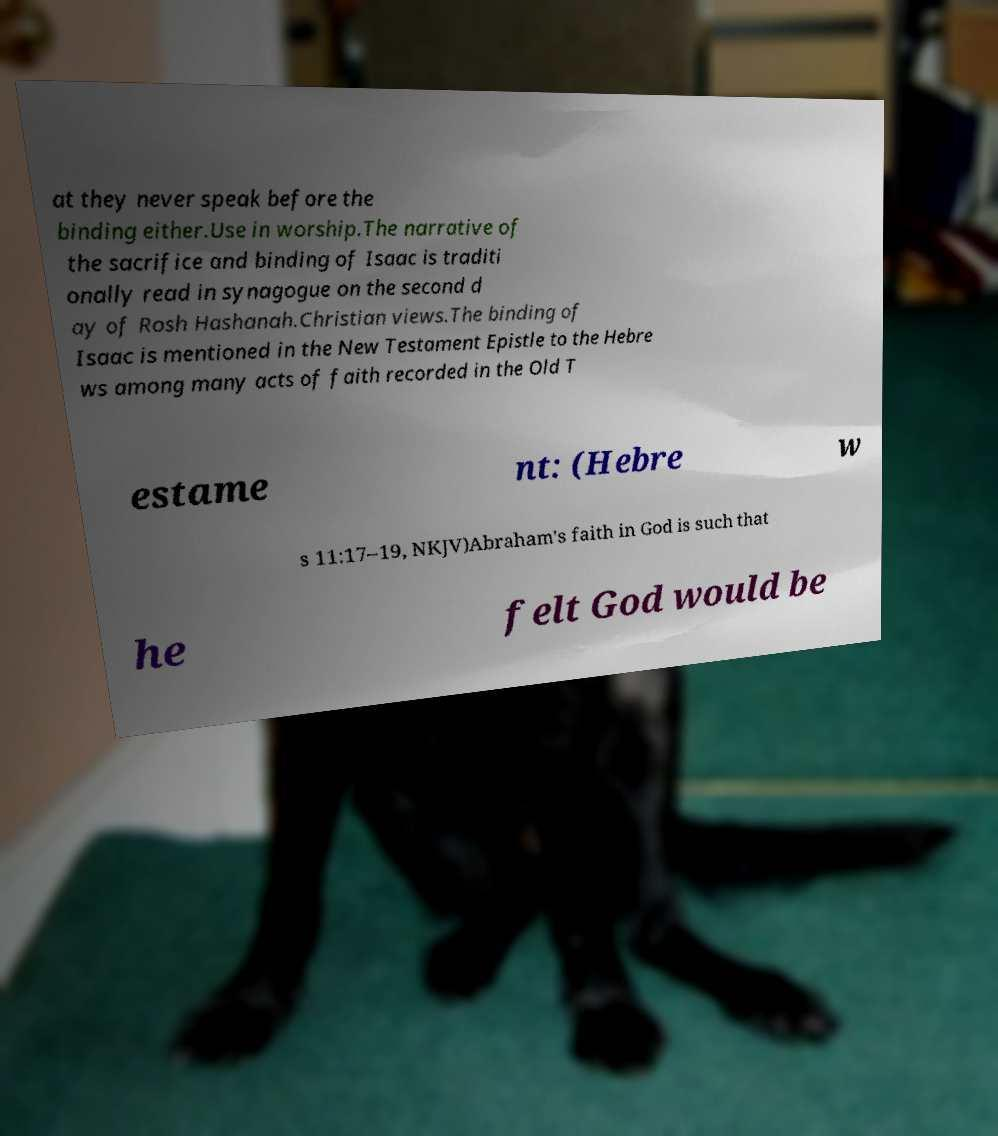Could you assist in decoding the text presented in this image and type it out clearly? at they never speak before the binding either.Use in worship.The narrative of the sacrifice and binding of Isaac is traditi onally read in synagogue on the second d ay of Rosh Hashanah.Christian views.The binding of Isaac is mentioned in the New Testament Epistle to the Hebre ws among many acts of faith recorded in the Old T estame nt: (Hebre w s 11:17–19, NKJV)Abraham's faith in God is such that he felt God would be 